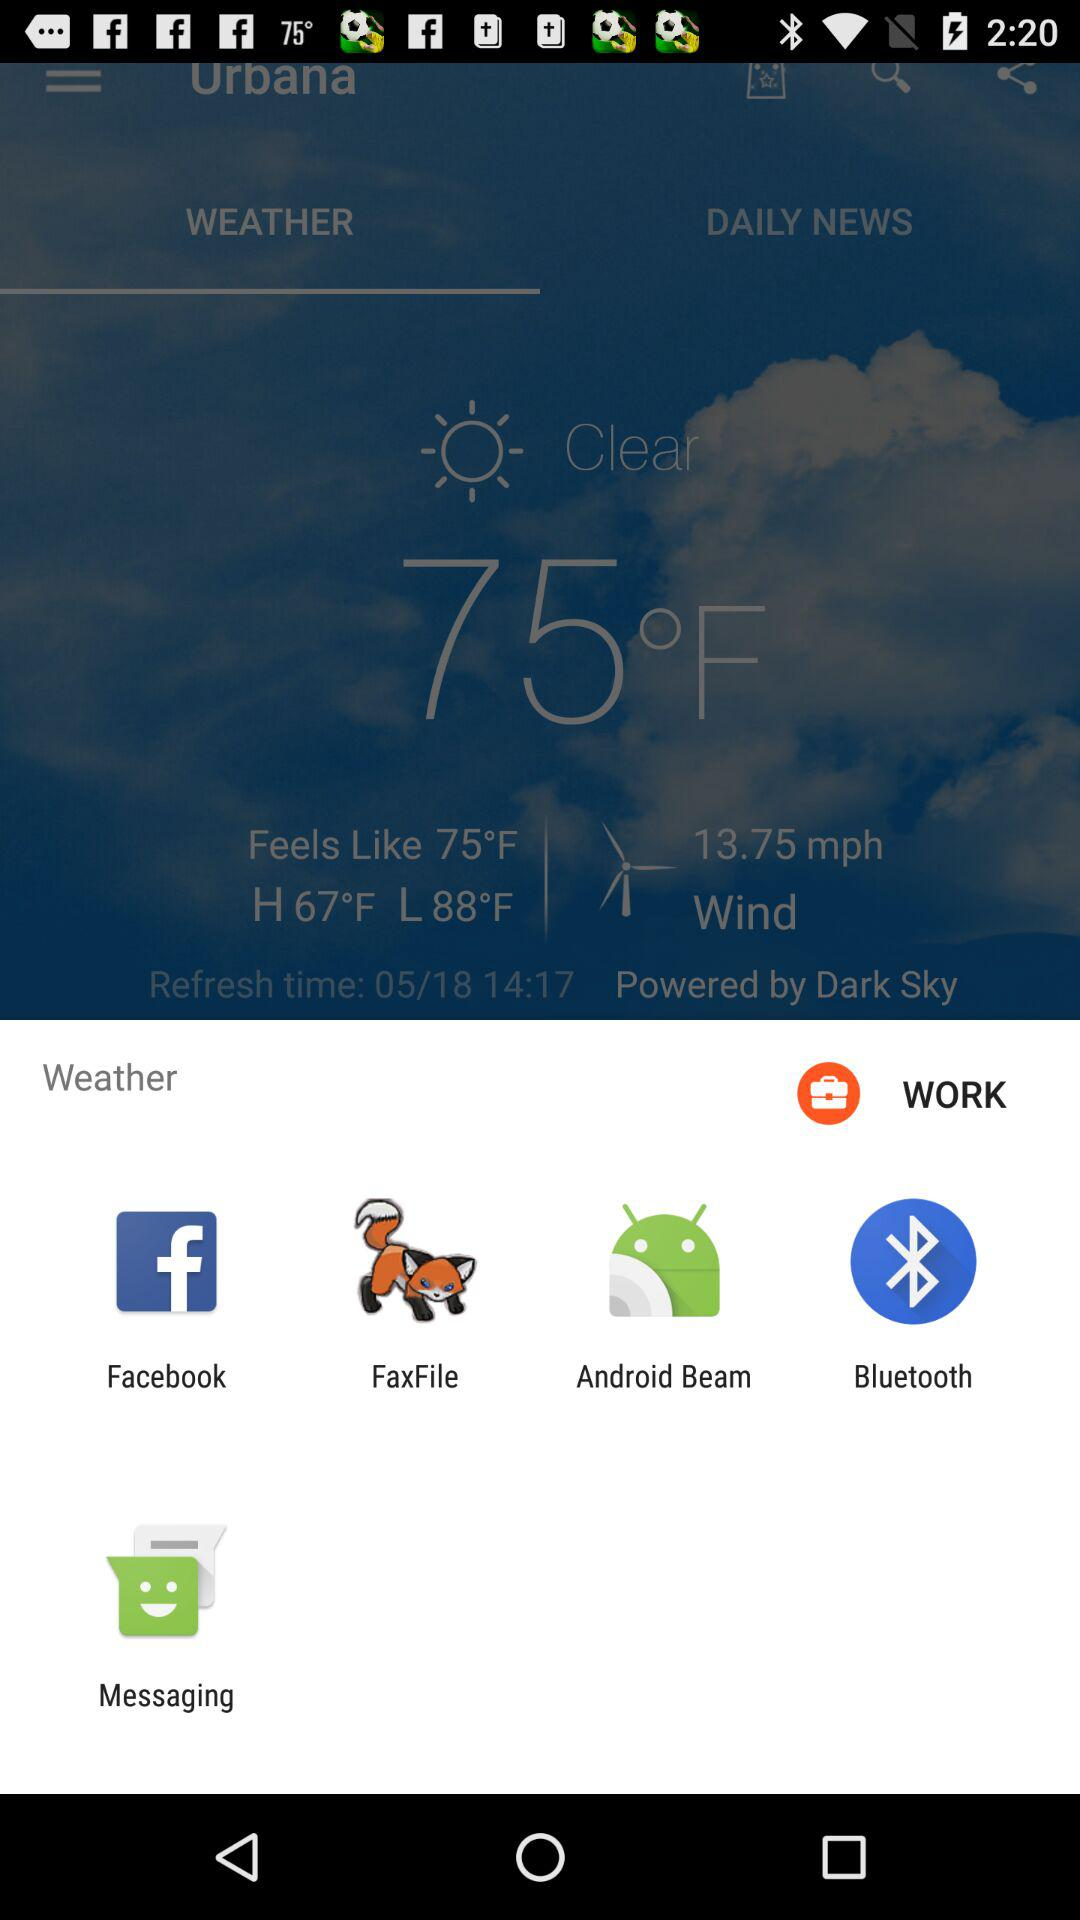What is the highest temperature? The highest temperature is 67 °F. 